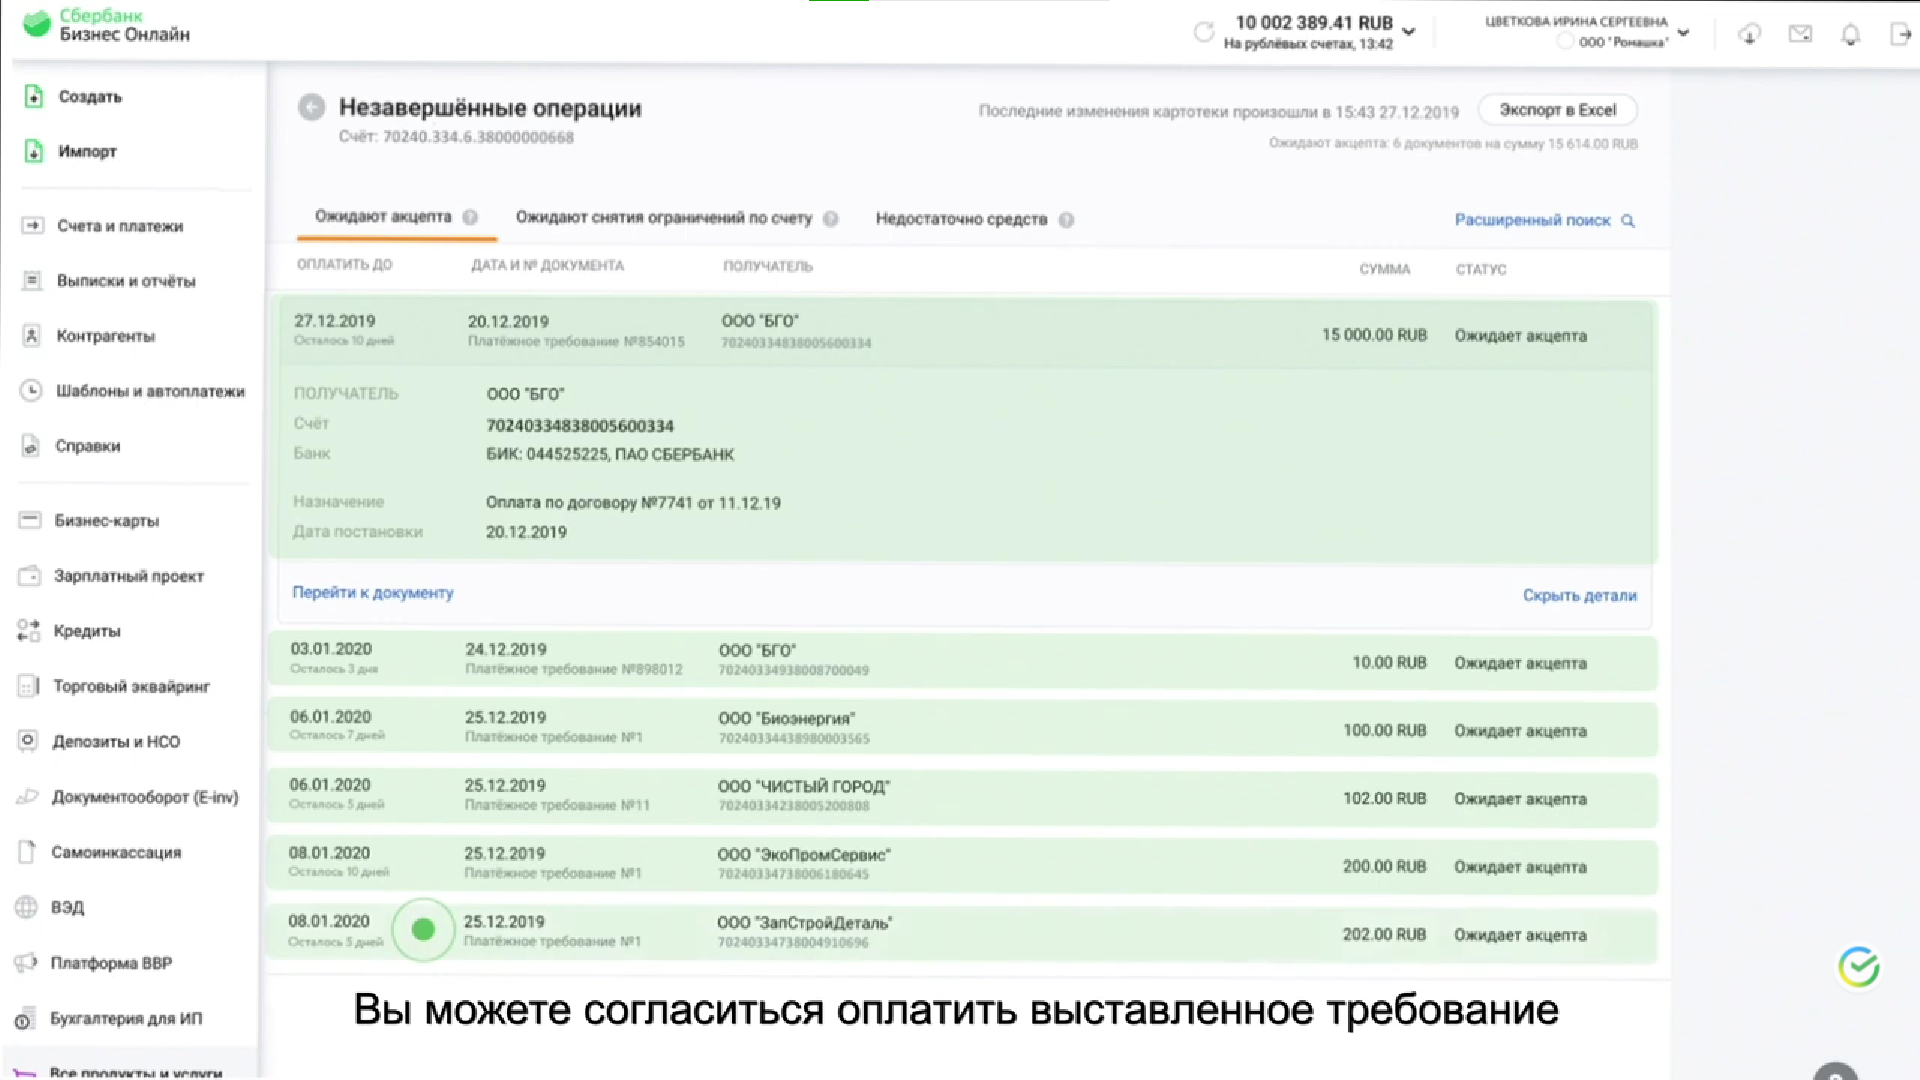Перечисли получателей незавершенных операций Получатели незавершенных операций:
* ООО "БГ" ИНН 702403347380000068
* ООО "Биоэнергия" ИНН 702403348980000034
* ООО "Чистый город" ИНН 702403348700000050
* ООО "ЭкоПрофСервис" ИНН 702403347800000085
* ООО "Санэксперт" ИНН 702403347380000091 